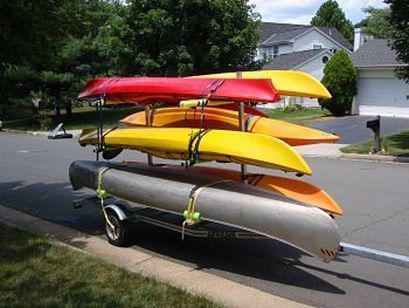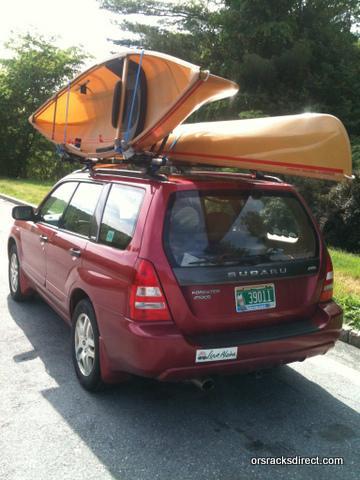The first image is the image on the left, the second image is the image on the right. Analyze the images presented: Is the assertion "Multiple boats are attached to the top of no less than one car" valid? Answer yes or no. Yes. The first image is the image on the left, the second image is the image on the right. Considering the images on both sides, is "At least one image shows a dark red SUV with multiple canoes on top." valid? Answer yes or no. Yes. 